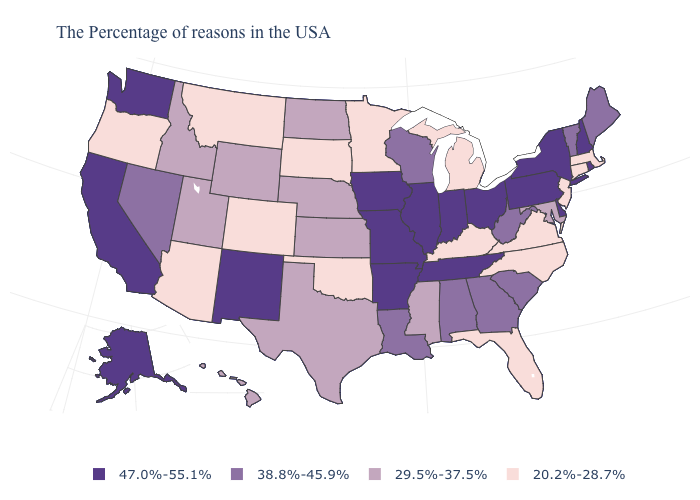Name the states that have a value in the range 38.8%-45.9%?
Give a very brief answer. Maine, Vermont, South Carolina, West Virginia, Georgia, Alabama, Wisconsin, Louisiana, Nevada. What is the value of Idaho?
Write a very short answer. 29.5%-37.5%. Name the states that have a value in the range 29.5%-37.5%?
Write a very short answer. Maryland, Mississippi, Kansas, Nebraska, Texas, North Dakota, Wyoming, Utah, Idaho, Hawaii. Does Arkansas have a higher value than Nebraska?
Answer briefly. Yes. What is the lowest value in the Northeast?
Quick response, please. 20.2%-28.7%. Does the first symbol in the legend represent the smallest category?
Concise answer only. No. Does Pennsylvania have the lowest value in the Northeast?
Keep it brief. No. How many symbols are there in the legend?
Keep it brief. 4. Among the states that border Maryland , does Pennsylvania have the highest value?
Quick response, please. Yes. What is the lowest value in the Northeast?
Keep it brief. 20.2%-28.7%. Among the states that border Montana , does North Dakota have the lowest value?
Concise answer only. No. Does Alaska have the highest value in the USA?
Write a very short answer. Yes. Which states hav the highest value in the West?
Concise answer only. New Mexico, California, Washington, Alaska. How many symbols are there in the legend?
Short answer required. 4. Does the map have missing data?
Concise answer only. No. 